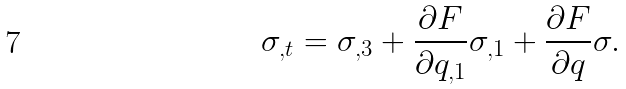<formula> <loc_0><loc_0><loc_500><loc_500>\sigma _ { , t } = \sigma _ { , 3 } + \frac { \partial F } { \partial q _ { , 1 } } \sigma _ { , 1 } + \frac { \partial F } { \partial q } \sigma .</formula> 